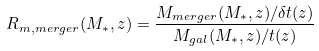Convert formula to latex. <formula><loc_0><loc_0><loc_500><loc_500>R _ { m , m e r g e r } ( M _ { * } , z ) = \frac { M _ { m e r g e r } ( M _ { * } , z ) / \delta t ( z ) } { M _ { g a l } ( M _ { * } , z ) / t ( z ) }</formula> 